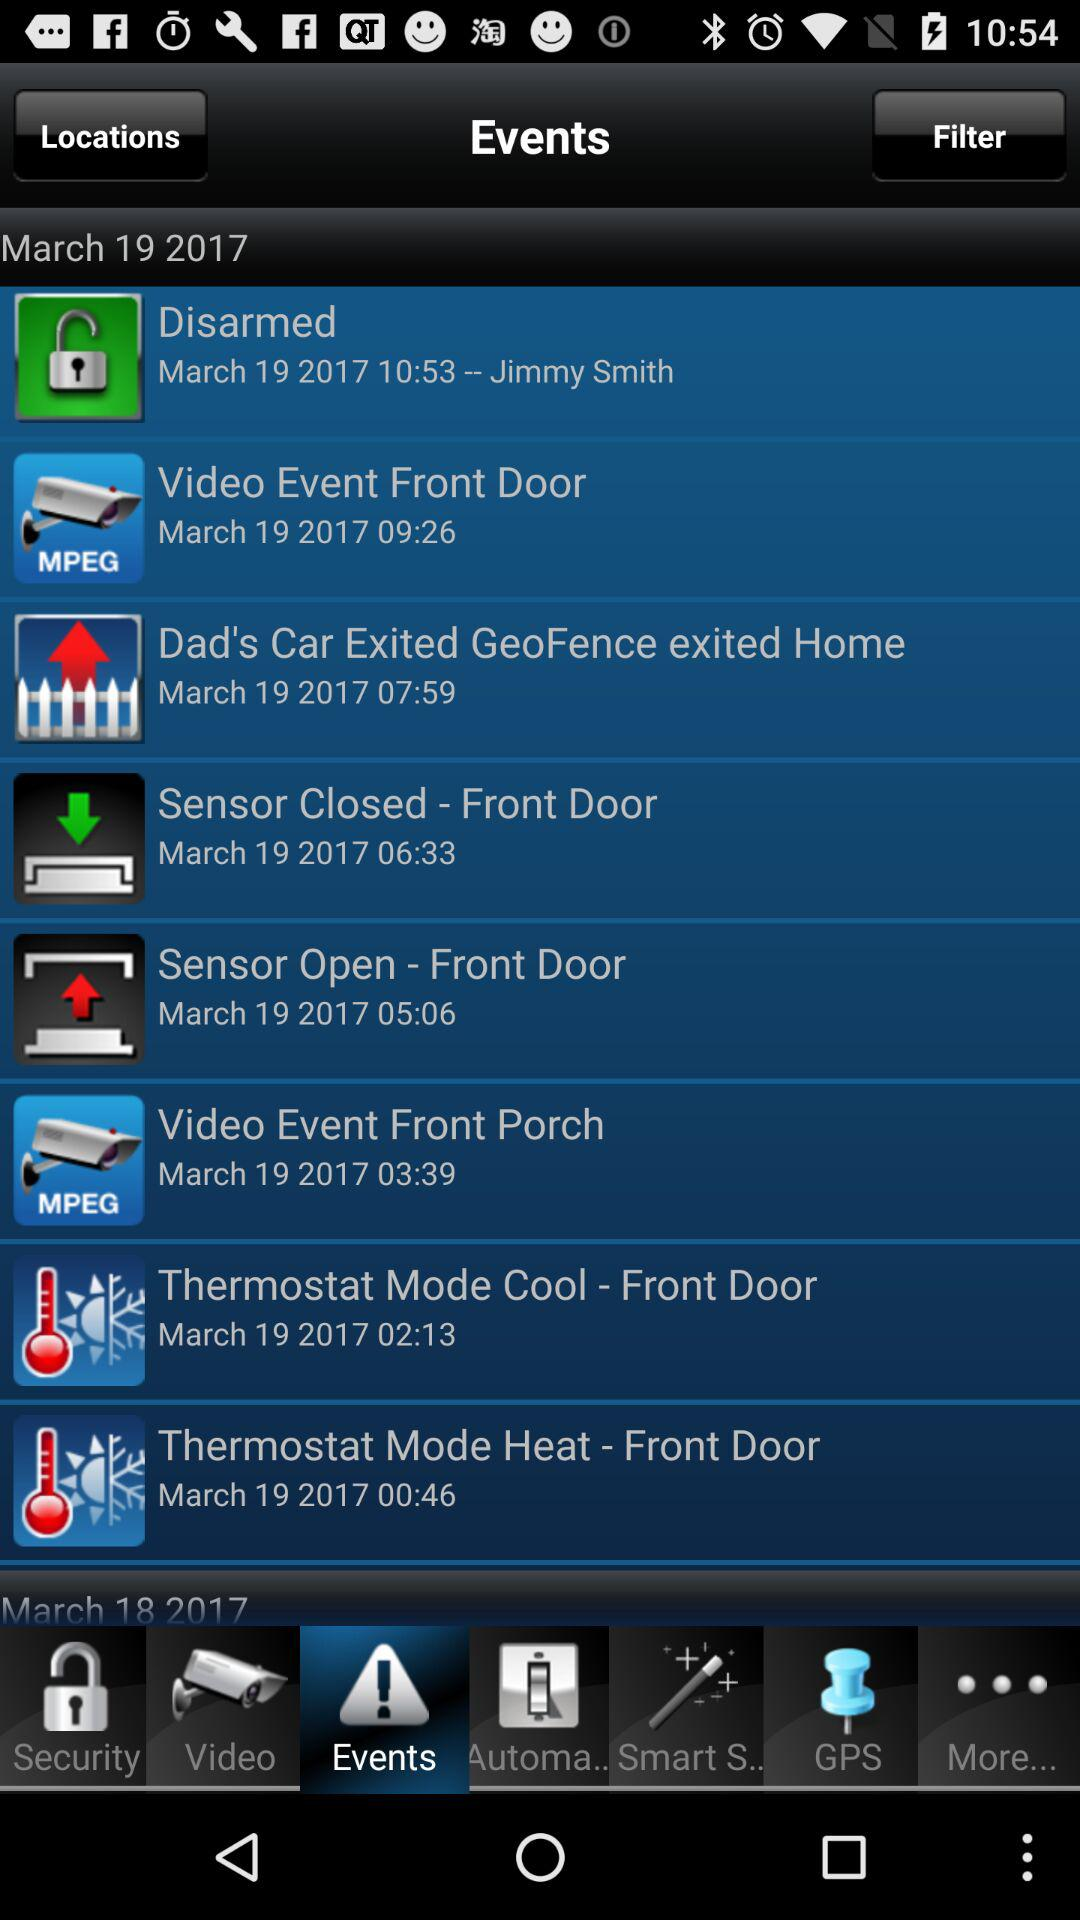Which tab has been selected? The selected tab is "Events". 